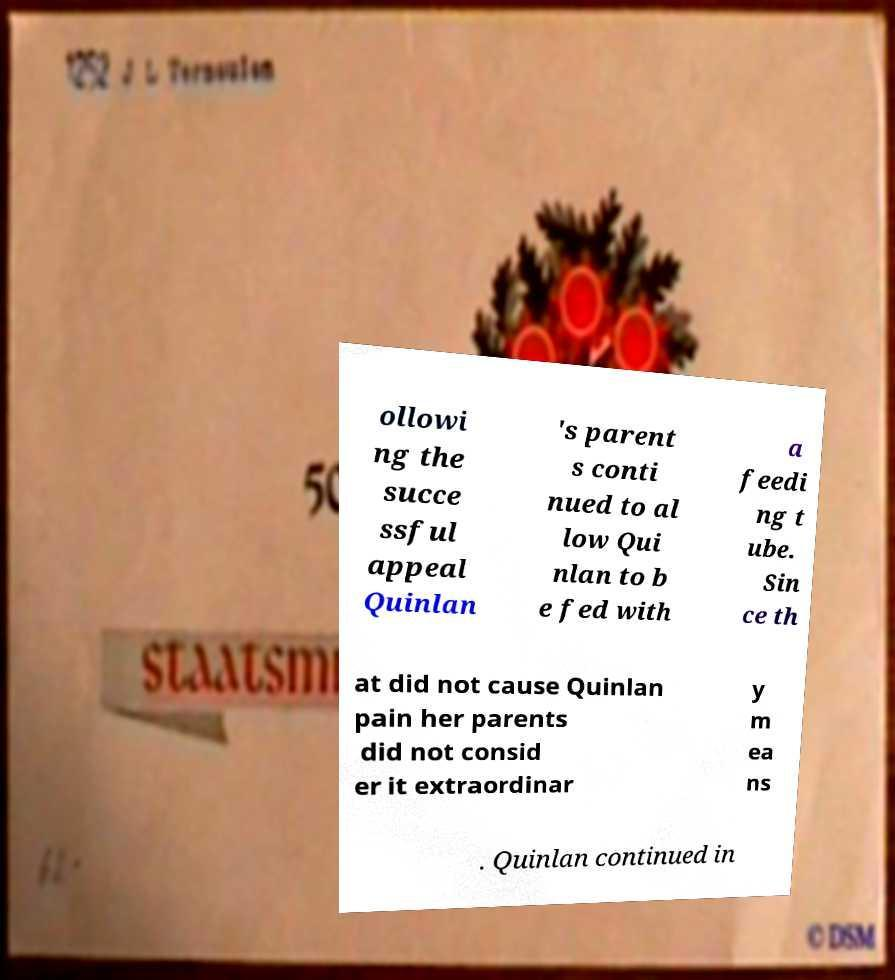Could you extract and type out the text from this image? ollowi ng the succe ssful appeal Quinlan 's parent s conti nued to al low Qui nlan to b e fed with a feedi ng t ube. Sin ce th at did not cause Quinlan pain her parents did not consid er it extraordinar y m ea ns . Quinlan continued in 